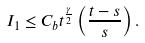Convert formula to latex. <formula><loc_0><loc_0><loc_500><loc_500>I _ { 1 } \leq C _ { b } t ^ { \frac { \gamma } { 2 } } \left ( \frac { t - s } { s } \right ) .</formula> 